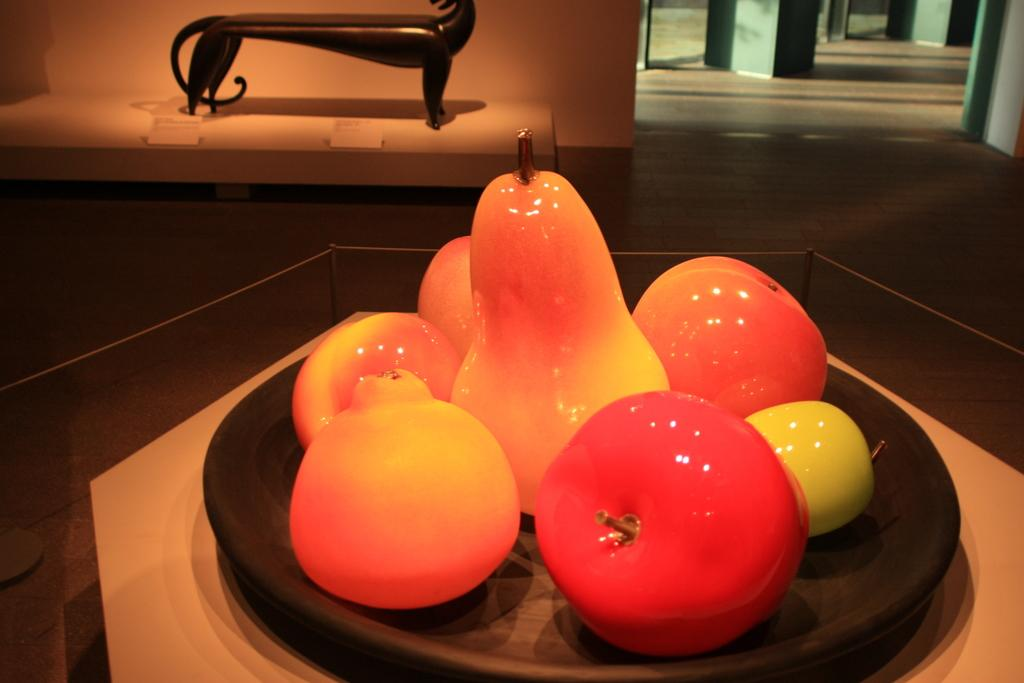What type of fruit can be seen in the image? There are pears in the image. Are there any other types of fruit besides pears? Yes, there are other fruits in the image. Where are the fruits placed? The fruits are on a plate. What is the plate resting on? The plate is on a glass table. Can you describe the wooden object in the background? The wooden object is on a white surface. What else can be seen in the background of the image? There is a wall and a floor in the background of the image. What type of flame can be seen coming from the doctor's hands in the image? There is no doctor or flame present in the image; it features fruits on a plate with a wooden object in the background. 